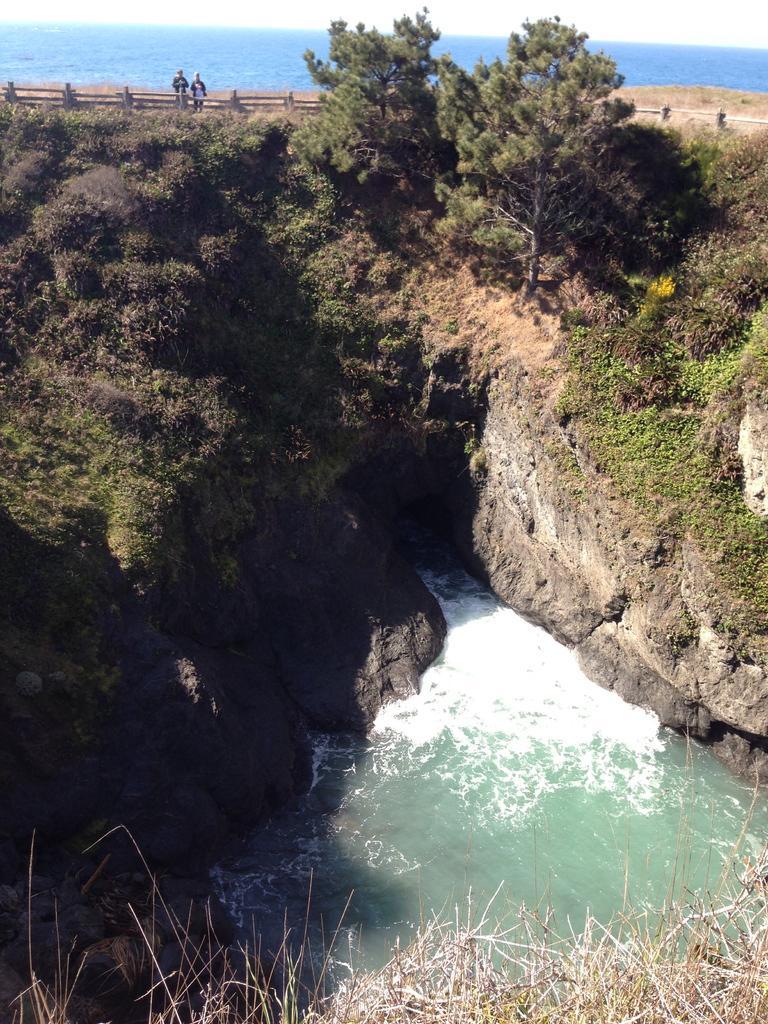In one or two sentences, can you explain what this image depicts? In this image I can see there is a mountain and there are two people standing at the wooden fence and there are trees and there is some water, there is an ocean in the backdrop and the sky is clear. 